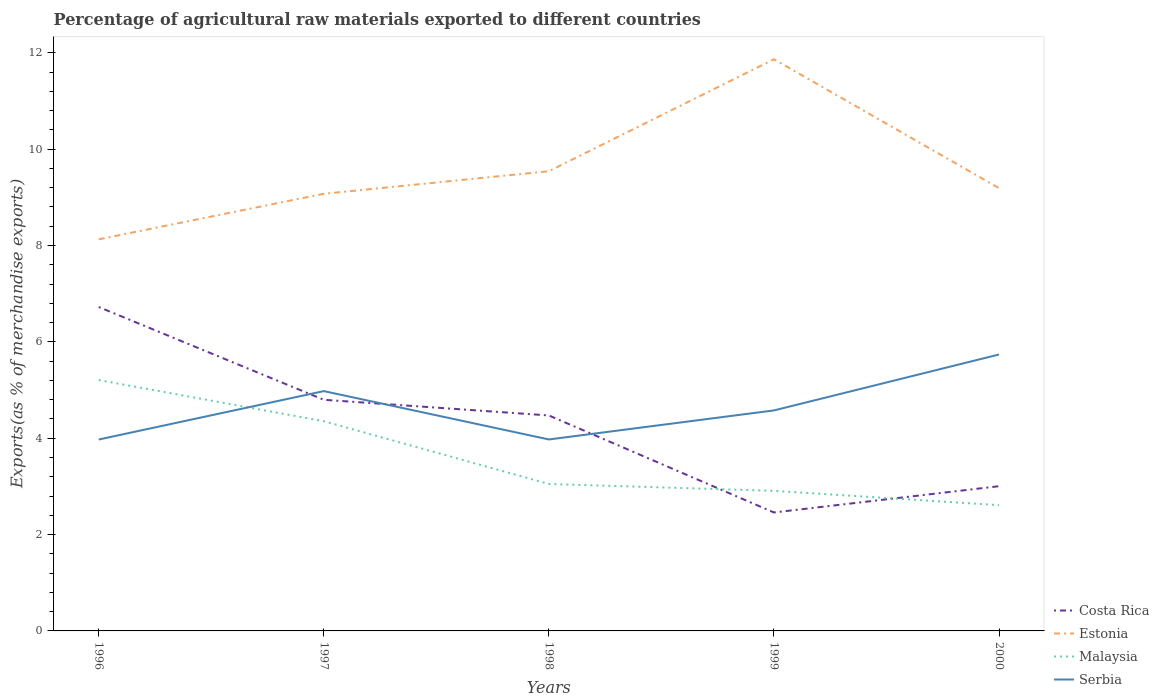How many different coloured lines are there?
Offer a very short reply. 4. Does the line corresponding to Costa Rica intersect with the line corresponding to Estonia?
Give a very brief answer. No. Across all years, what is the maximum percentage of exports to different countries in Serbia?
Provide a short and direct response. 3.97. In which year was the percentage of exports to different countries in Malaysia maximum?
Give a very brief answer. 2000. What is the total percentage of exports to different countries in Serbia in the graph?
Your answer should be very brief. -0. What is the difference between the highest and the second highest percentage of exports to different countries in Malaysia?
Provide a succinct answer. 2.6. What is the difference between the highest and the lowest percentage of exports to different countries in Malaysia?
Your response must be concise. 2. Are the values on the major ticks of Y-axis written in scientific E-notation?
Ensure brevity in your answer.  No. Where does the legend appear in the graph?
Give a very brief answer. Bottom right. How many legend labels are there?
Provide a succinct answer. 4. How are the legend labels stacked?
Make the answer very short. Vertical. What is the title of the graph?
Make the answer very short. Percentage of agricultural raw materials exported to different countries. What is the label or title of the Y-axis?
Provide a succinct answer. Exports(as % of merchandise exports). What is the Exports(as % of merchandise exports) in Costa Rica in 1996?
Your answer should be compact. 6.72. What is the Exports(as % of merchandise exports) of Estonia in 1996?
Offer a terse response. 8.13. What is the Exports(as % of merchandise exports) of Malaysia in 1996?
Your answer should be compact. 5.21. What is the Exports(as % of merchandise exports) in Serbia in 1996?
Your answer should be very brief. 3.97. What is the Exports(as % of merchandise exports) in Costa Rica in 1997?
Your response must be concise. 4.8. What is the Exports(as % of merchandise exports) of Estonia in 1997?
Give a very brief answer. 9.07. What is the Exports(as % of merchandise exports) of Malaysia in 1997?
Make the answer very short. 4.35. What is the Exports(as % of merchandise exports) of Serbia in 1997?
Offer a very short reply. 4.98. What is the Exports(as % of merchandise exports) in Costa Rica in 1998?
Your response must be concise. 4.47. What is the Exports(as % of merchandise exports) in Estonia in 1998?
Make the answer very short. 9.54. What is the Exports(as % of merchandise exports) in Malaysia in 1998?
Keep it short and to the point. 3.05. What is the Exports(as % of merchandise exports) of Serbia in 1998?
Your answer should be compact. 3.97. What is the Exports(as % of merchandise exports) of Costa Rica in 1999?
Give a very brief answer. 2.46. What is the Exports(as % of merchandise exports) in Estonia in 1999?
Your answer should be very brief. 11.87. What is the Exports(as % of merchandise exports) of Malaysia in 1999?
Offer a terse response. 2.91. What is the Exports(as % of merchandise exports) in Serbia in 1999?
Your response must be concise. 4.58. What is the Exports(as % of merchandise exports) in Costa Rica in 2000?
Your response must be concise. 3. What is the Exports(as % of merchandise exports) in Estonia in 2000?
Offer a terse response. 9.19. What is the Exports(as % of merchandise exports) in Malaysia in 2000?
Provide a short and direct response. 2.61. What is the Exports(as % of merchandise exports) of Serbia in 2000?
Make the answer very short. 5.74. Across all years, what is the maximum Exports(as % of merchandise exports) in Costa Rica?
Your answer should be compact. 6.72. Across all years, what is the maximum Exports(as % of merchandise exports) of Estonia?
Ensure brevity in your answer.  11.87. Across all years, what is the maximum Exports(as % of merchandise exports) in Malaysia?
Your answer should be compact. 5.21. Across all years, what is the maximum Exports(as % of merchandise exports) in Serbia?
Ensure brevity in your answer.  5.74. Across all years, what is the minimum Exports(as % of merchandise exports) of Costa Rica?
Your answer should be very brief. 2.46. Across all years, what is the minimum Exports(as % of merchandise exports) in Estonia?
Keep it short and to the point. 8.13. Across all years, what is the minimum Exports(as % of merchandise exports) in Malaysia?
Provide a short and direct response. 2.61. Across all years, what is the minimum Exports(as % of merchandise exports) of Serbia?
Give a very brief answer. 3.97. What is the total Exports(as % of merchandise exports) in Costa Rica in the graph?
Ensure brevity in your answer.  21.46. What is the total Exports(as % of merchandise exports) of Estonia in the graph?
Ensure brevity in your answer.  47.8. What is the total Exports(as % of merchandise exports) of Malaysia in the graph?
Provide a succinct answer. 18.13. What is the total Exports(as % of merchandise exports) of Serbia in the graph?
Offer a terse response. 23.24. What is the difference between the Exports(as % of merchandise exports) in Costa Rica in 1996 and that in 1997?
Your response must be concise. 1.93. What is the difference between the Exports(as % of merchandise exports) in Estonia in 1996 and that in 1997?
Provide a succinct answer. -0.94. What is the difference between the Exports(as % of merchandise exports) of Malaysia in 1996 and that in 1997?
Offer a very short reply. 0.85. What is the difference between the Exports(as % of merchandise exports) of Serbia in 1996 and that in 1997?
Give a very brief answer. -1. What is the difference between the Exports(as % of merchandise exports) of Costa Rica in 1996 and that in 1998?
Your answer should be compact. 2.25. What is the difference between the Exports(as % of merchandise exports) in Estonia in 1996 and that in 1998?
Give a very brief answer. -1.41. What is the difference between the Exports(as % of merchandise exports) in Malaysia in 1996 and that in 1998?
Offer a terse response. 2.16. What is the difference between the Exports(as % of merchandise exports) in Serbia in 1996 and that in 1998?
Ensure brevity in your answer.  -0. What is the difference between the Exports(as % of merchandise exports) in Costa Rica in 1996 and that in 1999?
Keep it short and to the point. 4.26. What is the difference between the Exports(as % of merchandise exports) in Estonia in 1996 and that in 1999?
Your answer should be compact. -3.74. What is the difference between the Exports(as % of merchandise exports) of Malaysia in 1996 and that in 1999?
Provide a short and direct response. 2.3. What is the difference between the Exports(as % of merchandise exports) of Serbia in 1996 and that in 1999?
Keep it short and to the point. -0.6. What is the difference between the Exports(as % of merchandise exports) of Costa Rica in 1996 and that in 2000?
Ensure brevity in your answer.  3.72. What is the difference between the Exports(as % of merchandise exports) of Estonia in 1996 and that in 2000?
Your answer should be compact. -1.06. What is the difference between the Exports(as % of merchandise exports) of Malaysia in 1996 and that in 2000?
Make the answer very short. 2.6. What is the difference between the Exports(as % of merchandise exports) in Serbia in 1996 and that in 2000?
Ensure brevity in your answer.  -1.76. What is the difference between the Exports(as % of merchandise exports) of Costa Rica in 1997 and that in 1998?
Provide a succinct answer. 0.33. What is the difference between the Exports(as % of merchandise exports) of Estonia in 1997 and that in 1998?
Provide a succinct answer. -0.47. What is the difference between the Exports(as % of merchandise exports) in Malaysia in 1997 and that in 1998?
Ensure brevity in your answer.  1.3. What is the difference between the Exports(as % of merchandise exports) in Serbia in 1997 and that in 1998?
Offer a very short reply. 1. What is the difference between the Exports(as % of merchandise exports) in Costa Rica in 1997 and that in 1999?
Provide a succinct answer. 2.34. What is the difference between the Exports(as % of merchandise exports) in Estonia in 1997 and that in 1999?
Ensure brevity in your answer.  -2.79. What is the difference between the Exports(as % of merchandise exports) in Malaysia in 1997 and that in 1999?
Offer a very short reply. 1.45. What is the difference between the Exports(as % of merchandise exports) of Serbia in 1997 and that in 1999?
Your answer should be compact. 0.4. What is the difference between the Exports(as % of merchandise exports) in Costa Rica in 1997 and that in 2000?
Your response must be concise. 1.79. What is the difference between the Exports(as % of merchandise exports) of Estonia in 1997 and that in 2000?
Give a very brief answer. -0.12. What is the difference between the Exports(as % of merchandise exports) of Malaysia in 1997 and that in 2000?
Your response must be concise. 1.74. What is the difference between the Exports(as % of merchandise exports) in Serbia in 1997 and that in 2000?
Keep it short and to the point. -0.76. What is the difference between the Exports(as % of merchandise exports) of Costa Rica in 1998 and that in 1999?
Offer a very short reply. 2.01. What is the difference between the Exports(as % of merchandise exports) in Estonia in 1998 and that in 1999?
Provide a succinct answer. -2.32. What is the difference between the Exports(as % of merchandise exports) of Malaysia in 1998 and that in 1999?
Your answer should be very brief. 0.14. What is the difference between the Exports(as % of merchandise exports) in Serbia in 1998 and that in 1999?
Your answer should be compact. -0.6. What is the difference between the Exports(as % of merchandise exports) of Costa Rica in 1998 and that in 2000?
Your answer should be compact. 1.47. What is the difference between the Exports(as % of merchandise exports) of Estonia in 1998 and that in 2000?
Offer a very short reply. 0.35. What is the difference between the Exports(as % of merchandise exports) of Malaysia in 1998 and that in 2000?
Provide a succinct answer. 0.44. What is the difference between the Exports(as % of merchandise exports) of Serbia in 1998 and that in 2000?
Keep it short and to the point. -1.76. What is the difference between the Exports(as % of merchandise exports) in Costa Rica in 1999 and that in 2000?
Provide a short and direct response. -0.55. What is the difference between the Exports(as % of merchandise exports) in Estonia in 1999 and that in 2000?
Offer a terse response. 2.68. What is the difference between the Exports(as % of merchandise exports) in Malaysia in 1999 and that in 2000?
Provide a short and direct response. 0.3. What is the difference between the Exports(as % of merchandise exports) in Serbia in 1999 and that in 2000?
Provide a short and direct response. -1.16. What is the difference between the Exports(as % of merchandise exports) in Costa Rica in 1996 and the Exports(as % of merchandise exports) in Estonia in 1997?
Offer a terse response. -2.35. What is the difference between the Exports(as % of merchandise exports) in Costa Rica in 1996 and the Exports(as % of merchandise exports) in Malaysia in 1997?
Offer a terse response. 2.37. What is the difference between the Exports(as % of merchandise exports) in Costa Rica in 1996 and the Exports(as % of merchandise exports) in Serbia in 1997?
Keep it short and to the point. 1.75. What is the difference between the Exports(as % of merchandise exports) of Estonia in 1996 and the Exports(as % of merchandise exports) of Malaysia in 1997?
Provide a succinct answer. 3.78. What is the difference between the Exports(as % of merchandise exports) of Estonia in 1996 and the Exports(as % of merchandise exports) of Serbia in 1997?
Offer a very short reply. 3.15. What is the difference between the Exports(as % of merchandise exports) in Malaysia in 1996 and the Exports(as % of merchandise exports) in Serbia in 1997?
Make the answer very short. 0.23. What is the difference between the Exports(as % of merchandise exports) in Costa Rica in 1996 and the Exports(as % of merchandise exports) in Estonia in 1998?
Provide a succinct answer. -2.82. What is the difference between the Exports(as % of merchandise exports) in Costa Rica in 1996 and the Exports(as % of merchandise exports) in Malaysia in 1998?
Keep it short and to the point. 3.67. What is the difference between the Exports(as % of merchandise exports) of Costa Rica in 1996 and the Exports(as % of merchandise exports) of Serbia in 1998?
Offer a terse response. 2.75. What is the difference between the Exports(as % of merchandise exports) in Estonia in 1996 and the Exports(as % of merchandise exports) in Malaysia in 1998?
Offer a very short reply. 5.08. What is the difference between the Exports(as % of merchandise exports) in Estonia in 1996 and the Exports(as % of merchandise exports) in Serbia in 1998?
Give a very brief answer. 4.15. What is the difference between the Exports(as % of merchandise exports) of Malaysia in 1996 and the Exports(as % of merchandise exports) of Serbia in 1998?
Give a very brief answer. 1.23. What is the difference between the Exports(as % of merchandise exports) in Costa Rica in 1996 and the Exports(as % of merchandise exports) in Estonia in 1999?
Provide a succinct answer. -5.14. What is the difference between the Exports(as % of merchandise exports) in Costa Rica in 1996 and the Exports(as % of merchandise exports) in Malaysia in 1999?
Give a very brief answer. 3.82. What is the difference between the Exports(as % of merchandise exports) of Costa Rica in 1996 and the Exports(as % of merchandise exports) of Serbia in 1999?
Provide a succinct answer. 2.15. What is the difference between the Exports(as % of merchandise exports) of Estonia in 1996 and the Exports(as % of merchandise exports) of Malaysia in 1999?
Your response must be concise. 5.22. What is the difference between the Exports(as % of merchandise exports) in Estonia in 1996 and the Exports(as % of merchandise exports) in Serbia in 1999?
Offer a terse response. 3.55. What is the difference between the Exports(as % of merchandise exports) in Malaysia in 1996 and the Exports(as % of merchandise exports) in Serbia in 1999?
Offer a very short reply. 0.63. What is the difference between the Exports(as % of merchandise exports) in Costa Rica in 1996 and the Exports(as % of merchandise exports) in Estonia in 2000?
Your answer should be very brief. -2.47. What is the difference between the Exports(as % of merchandise exports) in Costa Rica in 1996 and the Exports(as % of merchandise exports) in Malaysia in 2000?
Your answer should be very brief. 4.11. What is the difference between the Exports(as % of merchandise exports) of Costa Rica in 1996 and the Exports(as % of merchandise exports) of Serbia in 2000?
Keep it short and to the point. 0.99. What is the difference between the Exports(as % of merchandise exports) in Estonia in 1996 and the Exports(as % of merchandise exports) in Malaysia in 2000?
Make the answer very short. 5.52. What is the difference between the Exports(as % of merchandise exports) of Estonia in 1996 and the Exports(as % of merchandise exports) of Serbia in 2000?
Give a very brief answer. 2.39. What is the difference between the Exports(as % of merchandise exports) in Malaysia in 1996 and the Exports(as % of merchandise exports) in Serbia in 2000?
Your answer should be compact. -0.53. What is the difference between the Exports(as % of merchandise exports) of Costa Rica in 1997 and the Exports(as % of merchandise exports) of Estonia in 1998?
Your response must be concise. -4.74. What is the difference between the Exports(as % of merchandise exports) of Costa Rica in 1997 and the Exports(as % of merchandise exports) of Malaysia in 1998?
Provide a succinct answer. 1.75. What is the difference between the Exports(as % of merchandise exports) of Costa Rica in 1997 and the Exports(as % of merchandise exports) of Serbia in 1998?
Offer a terse response. 0.82. What is the difference between the Exports(as % of merchandise exports) in Estonia in 1997 and the Exports(as % of merchandise exports) in Malaysia in 1998?
Ensure brevity in your answer.  6.02. What is the difference between the Exports(as % of merchandise exports) in Estonia in 1997 and the Exports(as % of merchandise exports) in Serbia in 1998?
Ensure brevity in your answer.  5.1. What is the difference between the Exports(as % of merchandise exports) in Malaysia in 1997 and the Exports(as % of merchandise exports) in Serbia in 1998?
Give a very brief answer. 0.38. What is the difference between the Exports(as % of merchandise exports) in Costa Rica in 1997 and the Exports(as % of merchandise exports) in Estonia in 1999?
Provide a succinct answer. -7.07. What is the difference between the Exports(as % of merchandise exports) in Costa Rica in 1997 and the Exports(as % of merchandise exports) in Malaysia in 1999?
Provide a short and direct response. 1.89. What is the difference between the Exports(as % of merchandise exports) in Costa Rica in 1997 and the Exports(as % of merchandise exports) in Serbia in 1999?
Provide a succinct answer. 0.22. What is the difference between the Exports(as % of merchandise exports) of Estonia in 1997 and the Exports(as % of merchandise exports) of Malaysia in 1999?
Keep it short and to the point. 6.17. What is the difference between the Exports(as % of merchandise exports) of Estonia in 1997 and the Exports(as % of merchandise exports) of Serbia in 1999?
Offer a very short reply. 4.5. What is the difference between the Exports(as % of merchandise exports) of Malaysia in 1997 and the Exports(as % of merchandise exports) of Serbia in 1999?
Provide a succinct answer. -0.22. What is the difference between the Exports(as % of merchandise exports) of Costa Rica in 1997 and the Exports(as % of merchandise exports) of Estonia in 2000?
Ensure brevity in your answer.  -4.39. What is the difference between the Exports(as % of merchandise exports) in Costa Rica in 1997 and the Exports(as % of merchandise exports) in Malaysia in 2000?
Offer a terse response. 2.19. What is the difference between the Exports(as % of merchandise exports) of Costa Rica in 1997 and the Exports(as % of merchandise exports) of Serbia in 2000?
Your answer should be compact. -0.94. What is the difference between the Exports(as % of merchandise exports) of Estonia in 1997 and the Exports(as % of merchandise exports) of Malaysia in 2000?
Provide a succinct answer. 6.46. What is the difference between the Exports(as % of merchandise exports) of Estonia in 1997 and the Exports(as % of merchandise exports) of Serbia in 2000?
Offer a very short reply. 3.34. What is the difference between the Exports(as % of merchandise exports) of Malaysia in 1997 and the Exports(as % of merchandise exports) of Serbia in 2000?
Provide a succinct answer. -1.38. What is the difference between the Exports(as % of merchandise exports) in Costa Rica in 1998 and the Exports(as % of merchandise exports) in Estonia in 1999?
Keep it short and to the point. -7.39. What is the difference between the Exports(as % of merchandise exports) in Costa Rica in 1998 and the Exports(as % of merchandise exports) in Malaysia in 1999?
Offer a terse response. 1.56. What is the difference between the Exports(as % of merchandise exports) of Costa Rica in 1998 and the Exports(as % of merchandise exports) of Serbia in 1999?
Provide a succinct answer. -0.1. What is the difference between the Exports(as % of merchandise exports) in Estonia in 1998 and the Exports(as % of merchandise exports) in Malaysia in 1999?
Offer a terse response. 6.63. What is the difference between the Exports(as % of merchandise exports) in Estonia in 1998 and the Exports(as % of merchandise exports) in Serbia in 1999?
Give a very brief answer. 4.96. What is the difference between the Exports(as % of merchandise exports) in Malaysia in 1998 and the Exports(as % of merchandise exports) in Serbia in 1999?
Give a very brief answer. -1.53. What is the difference between the Exports(as % of merchandise exports) in Costa Rica in 1998 and the Exports(as % of merchandise exports) in Estonia in 2000?
Provide a short and direct response. -4.72. What is the difference between the Exports(as % of merchandise exports) in Costa Rica in 1998 and the Exports(as % of merchandise exports) in Malaysia in 2000?
Your answer should be very brief. 1.86. What is the difference between the Exports(as % of merchandise exports) in Costa Rica in 1998 and the Exports(as % of merchandise exports) in Serbia in 2000?
Give a very brief answer. -1.27. What is the difference between the Exports(as % of merchandise exports) in Estonia in 1998 and the Exports(as % of merchandise exports) in Malaysia in 2000?
Offer a terse response. 6.93. What is the difference between the Exports(as % of merchandise exports) of Estonia in 1998 and the Exports(as % of merchandise exports) of Serbia in 2000?
Make the answer very short. 3.8. What is the difference between the Exports(as % of merchandise exports) of Malaysia in 1998 and the Exports(as % of merchandise exports) of Serbia in 2000?
Offer a very short reply. -2.69. What is the difference between the Exports(as % of merchandise exports) in Costa Rica in 1999 and the Exports(as % of merchandise exports) in Estonia in 2000?
Your response must be concise. -6.73. What is the difference between the Exports(as % of merchandise exports) in Costa Rica in 1999 and the Exports(as % of merchandise exports) in Malaysia in 2000?
Your answer should be compact. -0.15. What is the difference between the Exports(as % of merchandise exports) in Costa Rica in 1999 and the Exports(as % of merchandise exports) in Serbia in 2000?
Give a very brief answer. -3.28. What is the difference between the Exports(as % of merchandise exports) in Estonia in 1999 and the Exports(as % of merchandise exports) in Malaysia in 2000?
Provide a succinct answer. 9.26. What is the difference between the Exports(as % of merchandise exports) in Estonia in 1999 and the Exports(as % of merchandise exports) in Serbia in 2000?
Keep it short and to the point. 6.13. What is the difference between the Exports(as % of merchandise exports) of Malaysia in 1999 and the Exports(as % of merchandise exports) of Serbia in 2000?
Make the answer very short. -2.83. What is the average Exports(as % of merchandise exports) of Costa Rica per year?
Offer a very short reply. 4.29. What is the average Exports(as % of merchandise exports) in Estonia per year?
Give a very brief answer. 9.56. What is the average Exports(as % of merchandise exports) of Malaysia per year?
Offer a very short reply. 3.63. What is the average Exports(as % of merchandise exports) in Serbia per year?
Offer a terse response. 4.65. In the year 1996, what is the difference between the Exports(as % of merchandise exports) in Costa Rica and Exports(as % of merchandise exports) in Estonia?
Your answer should be very brief. -1.41. In the year 1996, what is the difference between the Exports(as % of merchandise exports) in Costa Rica and Exports(as % of merchandise exports) in Malaysia?
Offer a very short reply. 1.52. In the year 1996, what is the difference between the Exports(as % of merchandise exports) in Costa Rica and Exports(as % of merchandise exports) in Serbia?
Keep it short and to the point. 2.75. In the year 1996, what is the difference between the Exports(as % of merchandise exports) in Estonia and Exports(as % of merchandise exports) in Malaysia?
Your answer should be very brief. 2.92. In the year 1996, what is the difference between the Exports(as % of merchandise exports) of Estonia and Exports(as % of merchandise exports) of Serbia?
Keep it short and to the point. 4.16. In the year 1996, what is the difference between the Exports(as % of merchandise exports) of Malaysia and Exports(as % of merchandise exports) of Serbia?
Your response must be concise. 1.23. In the year 1997, what is the difference between the Exports(as % of merchandise exports) of Costa Rica and Exports(as % of merchandise exports) of Estonia?
Provide a succinct answer. -4.28. In the year 1997, what is the difference between the Exports(as % of merchandise exports) of Costa Rica and Exports(as % of merchandise exports) of Malaysia?
Make the answer very short. 0.44. In the year 1997, what is the difference between the Exports(as % of merchandise exports) in Costa Rica and Exports(as % of merchandise exports) in Serbia?
Provide a short and direct response. -0.18. In the year 1997, what is the difference between the Exports(as % of merchandise exports) in Estonia and Exports(as % of merchandise exports) in Malaysia?
Keep it short and to the point. 4.72. In the year 1997, what is the difference between the Exports(as % of merchandise exports) in Estonia and Exports(as % of merchandise exports) in Serbia?
Make the answer very short. 4.1. In the year 1997, what is the difference between the Exports(as % of merchandise exports) of Malaysia and Exports(as % of merchandise exports) of Serbia?
Ensure brevity in your answer.  -0.62. In the year 1998, what is the difference between the Exports(as % of merchandise exports) of Costa Rica and Exports(as % of merchandise exports) of Estonia?
Offer a very short reply. -5.07. In the year 1998, what is the difference between the Exports(as % of merchandise exports) in Costa Rica and Exports(as % of merchandise exports) in Malaysia?
Make the answer very short. 1.42. In the year 1998, what is the difference between the Exports(as % of merchandise exports) of Costa Rica and Exports(as % of merchandise exports) of Serbia?
Provide a succinct answer. 0.5. In the year 1998, what is the difference between the Exports(as % of merchandise exports) in Estonia and Exports(as % of merchandise exports) in Malaysia?
Your answer should be very brief. 6.49. In the year 1998, what is the difference between the Exports(as % of merchandise exports) in Estonia and Exports(as % of merchandise exports) in Serbia?
Your answer should be very brief. 5.57. In the year 1998, what is the difference between the Exports(as % of merchandise exports) in Malaysia and Exports(as % of merchandise exports) in Serbia?
Make the answer very short. -0.92. In the year 1999, what is the difference between the Exports(as % of merchandise exports) in Costa Rica and Exports(as % of merchandise exports) in Estonia?
Ensure brevity in your answer.  -9.41. In the year 1999, what is the difference between the Exports(as % of merchandise exports) in Costa Rica and Exports(as % of merchandise exports) in Malaysia?
Ensure brevity in your answer.  -0.45. In the year 1999, what is the difference between the Exports(as % of merchandise exports) of Costa Rica and Exports(as % of merchandise exports) of Serbia?
Your answer should be compact. -2.12. In the year 1999, what is the difference between the Exports(as % of merchandise exports) in Estonia and Exports(as % of merchandise exports) in Malaysia?
Provide a succinct answer. 8.96. In the year 1999, what is the difference between the Exports(as % of merchandise exports) of Estonia and Exports(as % of merchandise exports) of Serbia?
Provide a short and direct response. 7.29. In the year 1999, what is the difference between the Exports(as % of merchandise exports) in Malaysia and Exports(as % of merchandise exports) in Serbia?
Ensure brevity in your answer.  -1.67. In the year 2000, what is the difference between the Exports(as % of merchandise exports) of Costa Rica and Exports(as % of merchandise exports) of Estonia?
Offer a very short reply. -6.19. In the year 2000, what is the difference between the Exports(as % of merchandise exports) of Costa Rica and Exports(as % of merchandise exports) of Malaysia?
Ensure brevity in your answer.  0.39. In the year 2000, what is the difference between the Exports(as % of merchandise exports) in Costa Rica and Exports(as % of merchandise exports) in Serbia?
Offer a very short reply. -2.73. In the year 2000, what is the difference between the Exports(as % of merchandise exports) of Estonia and Exports(as % of merchandise exports) of Malaysia?
Your answer should be compact. 6.58. In the year 2000, what is the difference between the Exports(as % of merchandise exports) of Estonia and Exports(as % of merchandise exports) of Serbia?
Make the answer very short. 3.45. In the year 2000, what is the difference between the Exports(as % of merchandise exports) of Malaysia and Exports(as % of merchandise exports) of Serbia?
Provide a short and direct response. -3.13. What is the ratio of the Exports(as % of merchandise exports) in Costa Rica in 1996 to that in 1997?
Offer a very short reply. 1.4. What is the ratio of the Exports(as % of merchandise exports) of Estonia in 1996 to that in 1997?
Your answer should be compact. 0.9. What is the ratio of the Exports(as % of merchandise exports) of Malaysia in 1996 to that in 1997?
Your answer should be compact. 1.2. What is the ratio of the Exports(as % of merchandise exports) of Serbia in 1996 to that in 1997?
Your answer should be very brief. 0.8. What is the ratio of the Exports(as % of merchandise exports) in Costa Rica in 1996 to that in 1998?
Your answer should be compact. 1.5. What is the ratio of the Exports(as % of merchandise exports) in Estonia in 1996 to that in 1998?
Keep it short and to the point. 0.85. What is the ratio of the Exports(as % of merchandise exports) of Malaysia in 1996 to that in 1998?
Provide a succinct answer. 1.71. What is the ratio of the Exports(as % of merchandise exports) in Costa Rica in 1996 to that in 1999?
Make the answer very short. 2.73. What is the ratio of the Exports(as % of merchandise exports) in Estonia in 1996 to that in 1999?
Offer a terse response. 0.69. What is the ratio of the Exports(as % of merchandise exports) in Malaysia in 1996 to that in 1999?
Offer a very short reply. 1.79. What is the ratio of the Exports(as % of merchandise exports) in Serbia in 1996 to that in 1999?
Keep it short and to the point. 0.87. What is the ratio of the Exports(as % of merchandise exports) in Costa Rica in 1996 to that in 2000?
Offer a terse response. 2.24. What is the ratio of the Exports(as % of merchandise exports) of Estonia in 1996 to that in 2000?
Your answer should be very brief. 0.88. What is the ratio of the Exports(as % of merchandise exports) in Malaysia in 1996 to that in 2000?
Give a very brief answer. 1.99. What is the ratio of the Exports(as % of merchandise exports) of Serbia in 1996 to that in 2000?
Your response must be concise. 0.69. What is the ratio of the Exports(as % of merchandise exports) of Costa Rica in 1997 to that in 1998?
Your answer should be compact. 1.07. What is the ratio of the Exports(as % of merchandise exports) in Estonia in 1997 to that in 1998?
Provide a succinct answer. 0.95. What is the ratio of the Exports(as % of merchandise exports) in Malaysia in 1997 to that in 1998?
Give a very brief answer. 1.43. What is the ratio of the Exports(as % of merchandise exports) in Serbia in 1997 to that in 1998?
Ensure brevity in your answer.  1.25. What is the ratio of the Exports(as % of merchandise exports) in Costa Rica in 1997 to that in 1999?
Offer a very short reply. 1.95. What is the ratio of the Exports(as % of merchandise exports) in Estonia in 1997 to that in 1999?
Keep it short and to the point. 0.76. What is the ratio of the Exports(as % of merchandise exports) of Malaysia in 1997 to that in 1999?
Offer a very short reply. 1.5. What is the ratio of the Exports(as % of merchandise exports) in Serbia in 1997 to that in 1999?
Your answer should be compact. 1.09. What is the ratio of the Exports(as % of merchandise exports) in Costa Rica in 1997 to that in 2000?
Keep it short and to the point. 1.6. What is the ratio of the Exports(as % of merchandise exports) in Estonia in 1997 to that in 2000?
Your answer should be very brief. 0.99. What is the ratio of the Exports(as % of merchandise exports) in Malaysia in 1997 to that in 2000?
Your answer should be compact. 1.67. What is the ratio of the Exports(as % of merchandise exports) in Serbia in 1997 to that in 2000?
Make the answer very short. 0.87. What is the ratio of the Exports(as % of merchandise exports) in Costa Rica in 1998 to that in 1999?
Provide a short and direct response. 1.82. What is the ratio of the Exports(as % of merchandise exports) in Estonia in 1998 to that in 1999?
Make the answer very short. 0.8. What is the ratio of the Exports(as % of merchandise exports) in Malaysia in 1998 to that in 1999?
Your answer should be compact. 1.05. What is the ratio of the Exports(as % of merchandise exports) of Serbia in 1998 to that in 1999?
Keep it short and to the point. 0.87. What is the ratio of the Exports(as % of merchandise exports) in Costa Rica in 1998 to that in 2000?
Offer a very short reply. 1.49. What is the ratio of the Exports(as % of merchandise exports) of Estonia in 1998 to that in 2000?
Offer a very short reply. 1.04. What is the ratio of the Exports(as % of merchandise exports) in Malaysia in 1998 to that in 2000?
Give a very brief answer. 1.17. What is the ratio of the Exports(as % of merchandise exports) in Serbia in 1998 to that in 2000?
Offer a very short reply. 0.69. What is the ratio of the Exports(as % of merchandise exports) in Costa Rica in 1999 to that in 2000?
Your answer should be compact. 0.82. What is the ratio of the Exports(as % of merchandise exports) of Estonia in 1999 to that in 2000?
Your answer should be compact. 1.29. What is the ratio of the Exports(as % of merchandise exports) of Malaysia in 1999 to that in 2000?
Offer a terse response. 1.11. What is the ratio of the Exports(as % of merchandise exports) in Serbia in 1999 to that in 2000?
Offer a very short reply. 0.8. What is the difference between the highest and the second highest Exports(as % of merchandise exports) in Costa Rica?
Provide a short and direct response. 1.93. What is the difference between the highest and the second highest Exports(as % of merchandise exports) of Estonia?
Give a very brief answer. 2.32. What is the difference between the highest and the second highest Exports(as % of merchandise exports) in Malaysia?
Make the answer very short. 0.85. What is the difference between the highest and the second highest Exports(as % of merchandise exports) in Serbia?
Keep it short and to the point. 0.76. What is the difference between the highest and the lowest Exports(as % of merchandise exports) in Costa Rica?
Your response must be concise. 4.26. What is the difference between the highest and the lowest Exports(as % of merchandise exports) of Estonia?
Keep it short and to the point. 3.74. What is the difference between the highest and the lowest Exports(as % of merchandise exports) of Malaysia?
Offer a terse response. 2.6. What is the difference between the highest and the lowest Exports(as % of merchandise exports) of Serbia?
Keep it short and to the point. 1.76. 